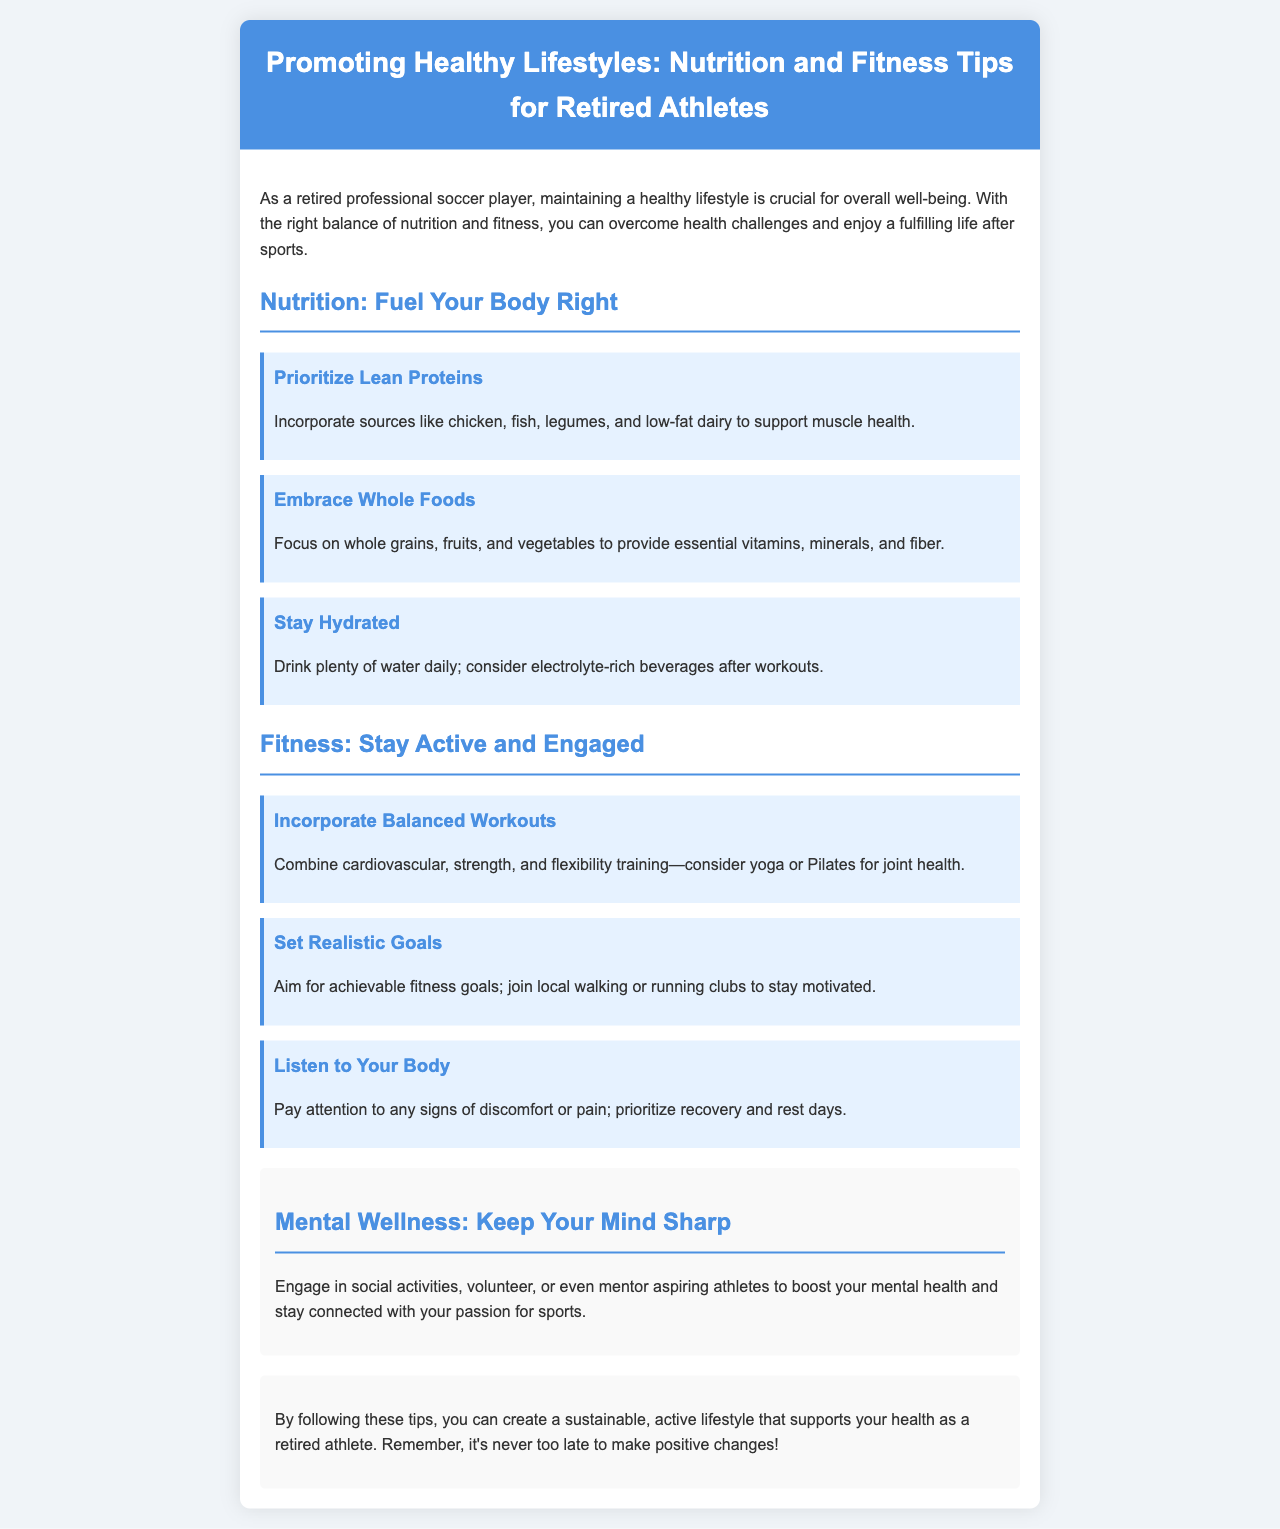What is the title of the brochure? The title is prominently displayed at the top of the document.
Answer: Promoting Healthy Lifestyles: Nutrition and Fitness Tips for Retired Athletes What are the three types of nutrition tips mentioned? The document specifies three categories of tips under nutrition.
Answer: Lean Proteins, Whole Foods, Stay Hydrated What should you incorporate for muscle health? The tip specifically mentions food sources that support muscle health.
Answer: Lean Proteins What is suggested for joint health? The text explicitly mentions a type of training beneficial for joint health.
Answer: Yoga or Pilates What should you aim for in your fitness goals? The document advises on setting achievable targets in fitness.
Answer: Achievable fitness goals What is a recommended activity for mental wellness? The section on mental wellness suggests a specific way to engage socially.
Answer: Mentor aspiring athletes How can you stay hydrated according to the document? The hydration tip indicates specific drinks to maintain hydration.
Answer: Drink plenty of water What is emphasized as important when working out? The fitness tip advises on being mindful during exercise.
Answer: Listen to Your Body 